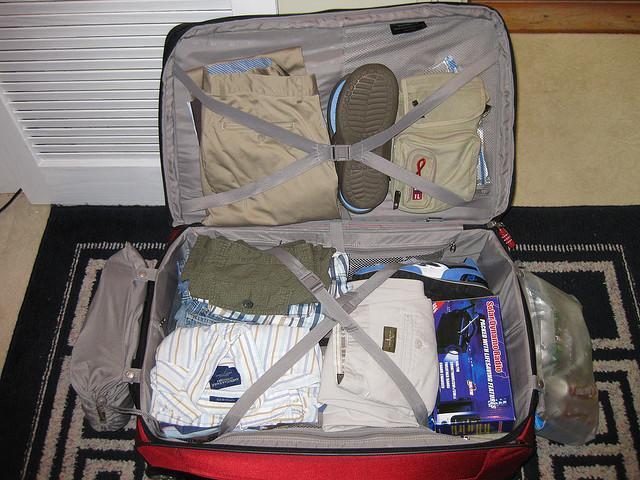How many pairs  of pants are visible?
Give a very brief answer. 2. 